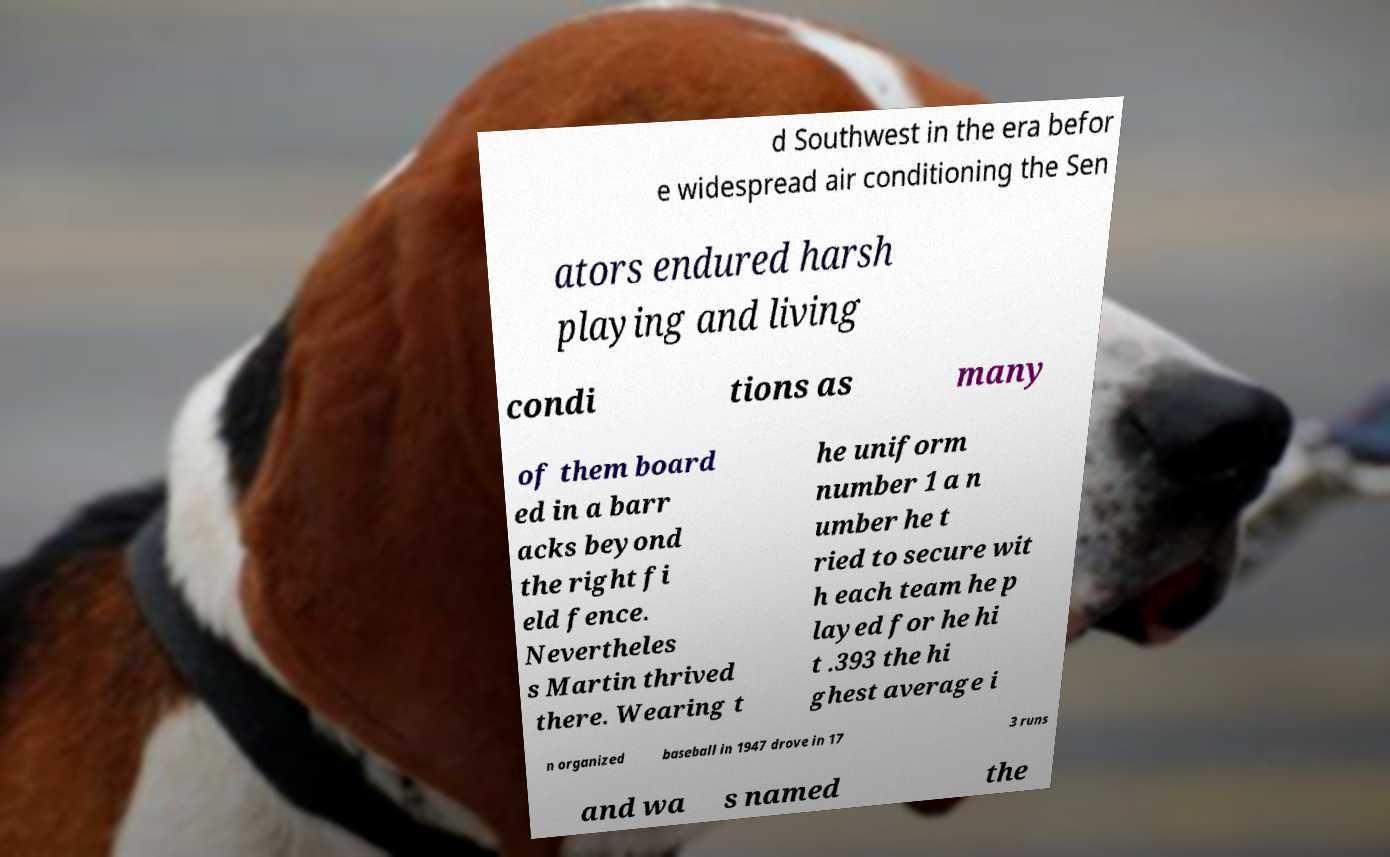For documentation purposes, I need the text within this image transcribed. Could you provide that? d Southwest in the era befor e widespread air conditioning the Sen ators endured harsh playing and living condi tions as many of them board ed in a barr acks beyond the right fi eld fence. Nevertheles s Martin thrived there. Wearing t he uniform number 1 a n umber he t ried to secure wit h each team he p layed for he hi t .393 the hi ghest average i n organized baseball in 1947 drove in 17 3 runs and wa s named the 